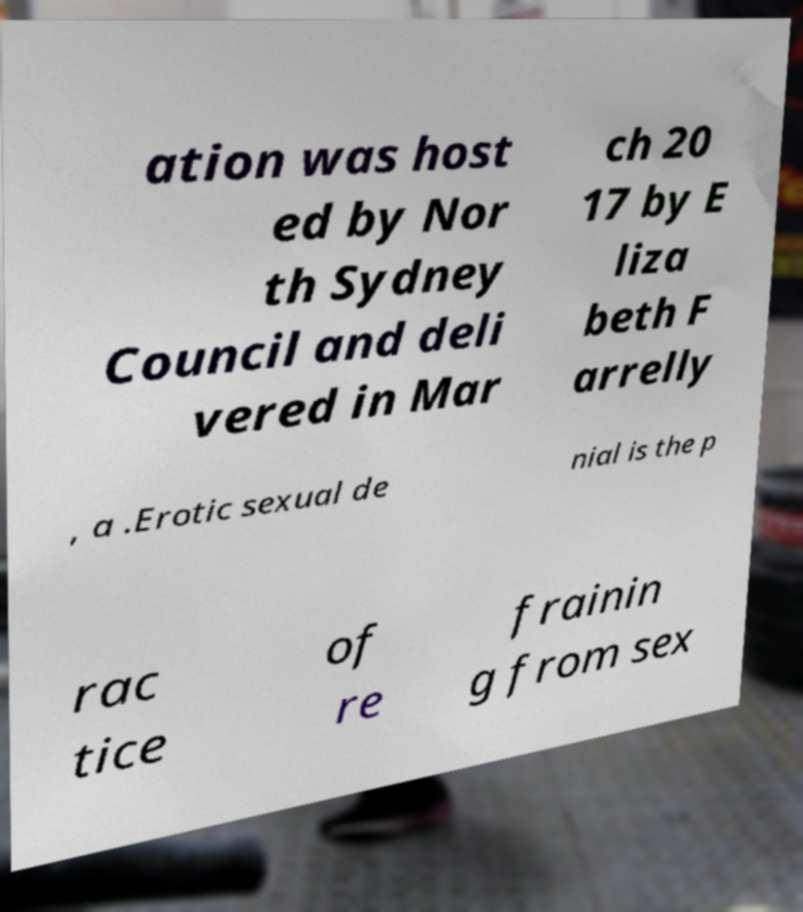For documentation purposes, I need the text within this image transcribed. Could you provide that? ation was host ed by Nor th Sydney Council and deli vered in Mar ch 20 17 by E liza beth F arrelly , a .Erotic sexual de nial is the p rac tice of re frainin g from sex 